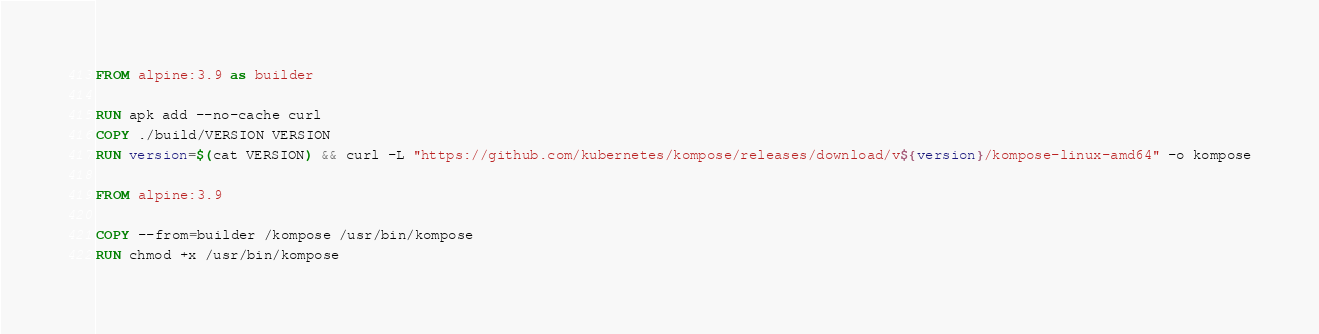<code> <loc_0><loc_0><loc_500><loc_500><_Dockerfile_>FROM alpine:3.9 as builder

RUN apk add --no-cache curl
COPY ./build/VERSION VERSION
RUN version=$(cat VERSION) && curl -L "https://github.com/kubernetes/kompose/releases/download/v${version}/kompose-linux-amd64" -o kompose

FROM alpine:3.9

COPY --from=builder /kompose /usr/bin/kompose
RUN chmod +x /usr/bin/kompose
</code> 